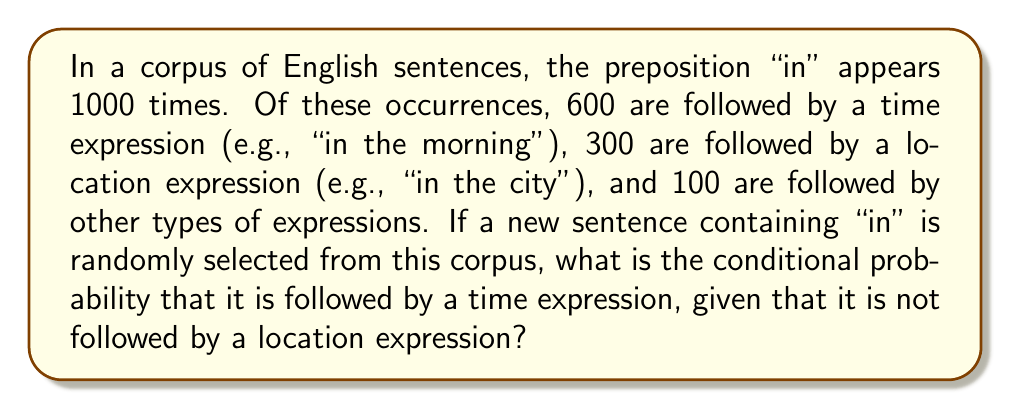Show me your answer to this math problem. Let's approach this step-by-step using conditional probability:

1. Define events:
   T: "in" is followed by a time expression
   L: "in" is followed by a location expression

2. Given information:
   P(T) = 600/1000 = 0.6
   P(L) = 300/1000 = 0.3
   P(not L) = 1 - P(L) = 1 - 0.3 = 0.7

3. We need to find P(T | not L), which is the probability of T given that L does not occur.

4. Use the formula for conditional probability:
   $$P(T | \text{not } L) = \frac{P(T \text{ and not } L)}{P(\text{not } L)}$$

5. Calculate P(T and not L):
   P(T and not L) = P(T) - P(T and L)
   P(T and L) = 0 (as an occurrence can't be both time and location)
   So, P(T and not L) = 0.6 - 0 = 0.6

6. Apply the formula:
   $$P(T | \text{not } L) = \frac{0.6}{0.7} \approx 0.8571$$
Answer: $\frac{6}{7} \approx 0.8571$ 